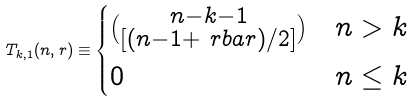<formula> <loc_0><loc_0><loc_500><loc_500>T _ { k , 1 } ( n , r ) \equiv \begin{cases} \binom { n - k - 1 } { [ ( n - 1 + \ r b a r ) / 2 ] } & n > k \\ 0 & n \leq k \end{cases}</formula> 